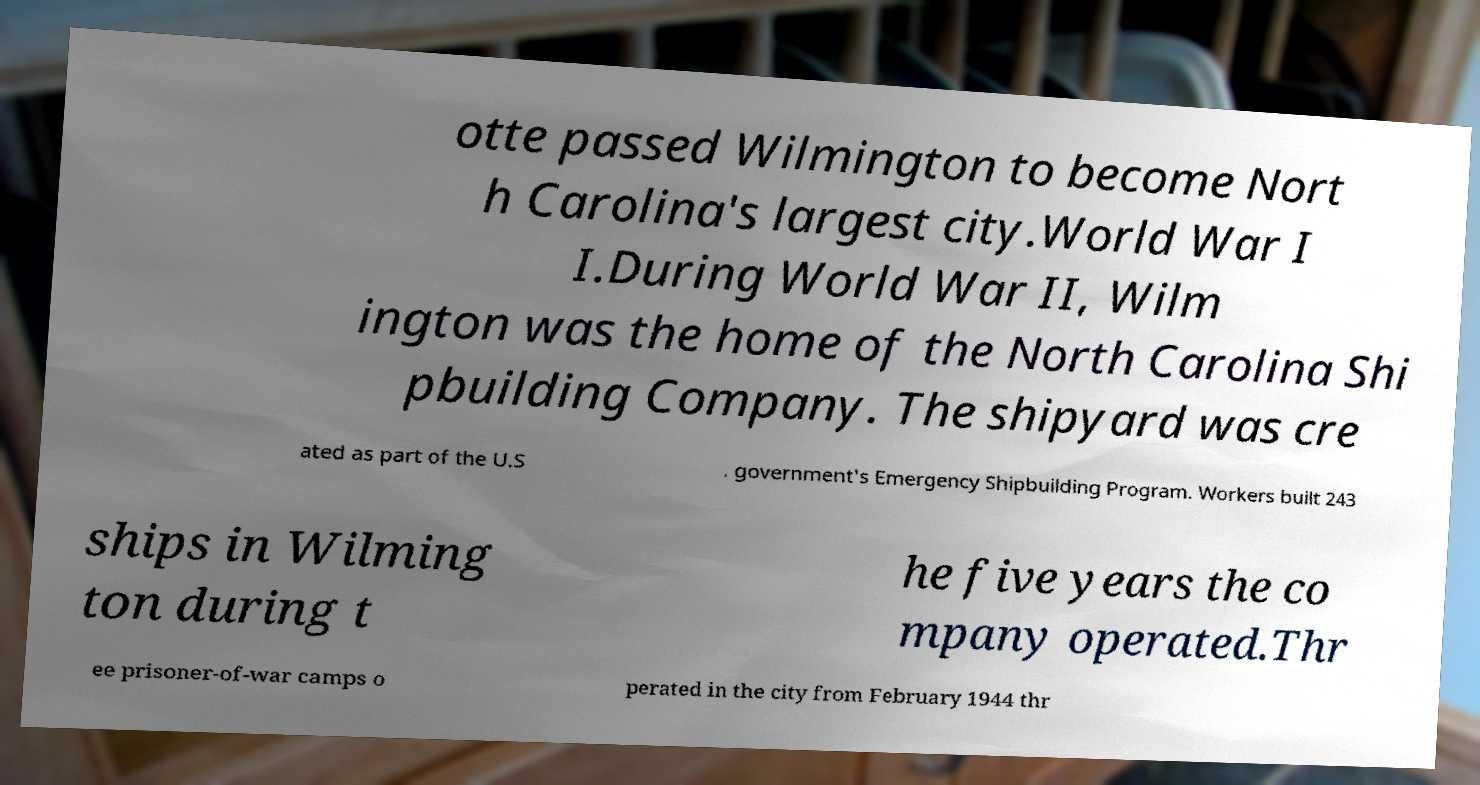What messages or text are displayed in this image? I need them in a readable, typed format. otte passed Wilmington to become Nort h Carolina's largest city.World War I I.During World War II, Wilm ington was the home of the North Carolina Shi pbuilding Company. The shipyard was cre ated as part of the U.S . government's Emergency Shipbuilding Program. Workers built 243 ships in Wilming ton during t he five years the co mpany operated.Thr ee prisoner-of-war camps o perated in the city from February 1944 thr 